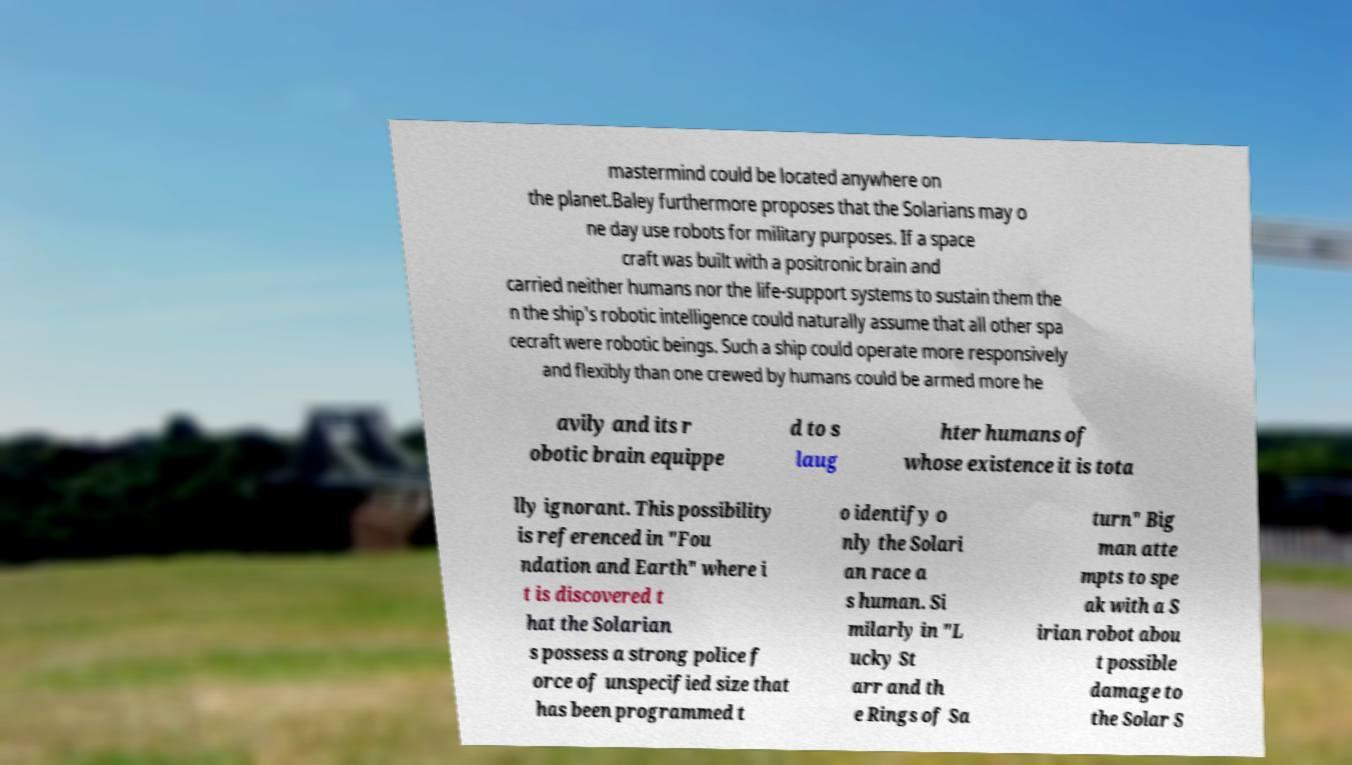For documentation purposes, I need the text within this image transcribed. Could you provide that? mastermind could be located anywhere on the planet.Baley furthermore proposes that the Solarians may o ne day use robots for military purposes. If a space craft was built with a positronic brain and carried neither humans nor the life-support systems to sustain them the n the ship's robotic intelligence could naturally assume that all other spa cecraft were robotic beings. Such a ship could operate more responsively and flexibly than one crewed by humans could be armed more he avily and its r obotic brain equippe d to s laug hter humans of whose existence it is tota lly ignorant. This possibility is referenced in "Fou ndation and Earth" where i t is discovered t hat the Solarian s possess a strong police f orce of unspecified size that has been programmed t o identify o nly the Solari an race a s human. Si milarly in "L ucky St arr and th e Rings of Sa turn" Big man atte mpts to spe ak with a S irian robot abou t possible damage to the Solar S 